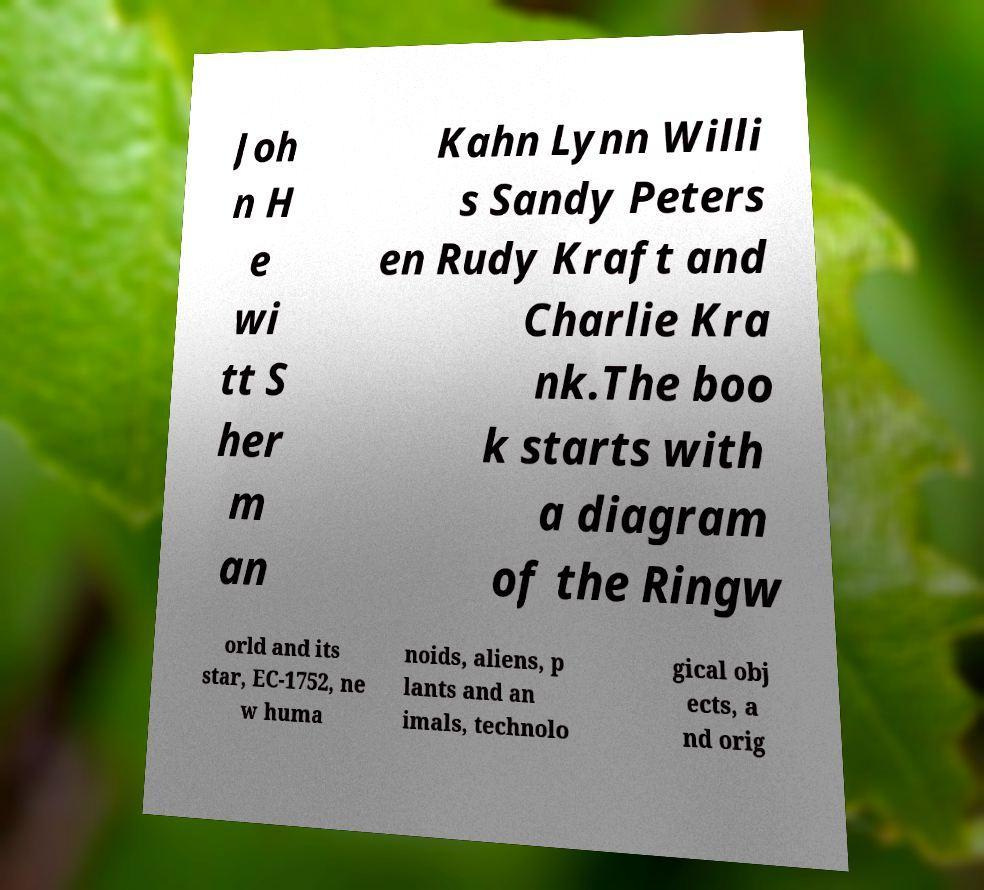Could you assist in decoding the text presented in this image and type it out clearly? Joh n H e wi tt S her m an Kahn Lynn Willi s Sandy Peters en Rudy Kraft and Charlie Kra nk.The boo k starts with a diagram of the Ringw orld and its star, EC-1752, ne w huma noids, aliens, p lants and an imals, technolo gical obj ects, a nd orig 